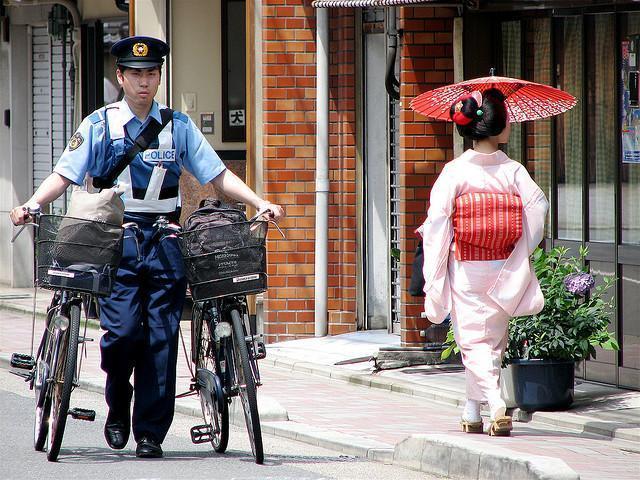How many bikes does the police have?
Give a very brief answer. 2. How many backpacks are visible?
Give a very brief answer. 2. How many people are there?
Give a very brief answer. 2. How many bicycles are in the picture?
Give a very brief answer. 2. 